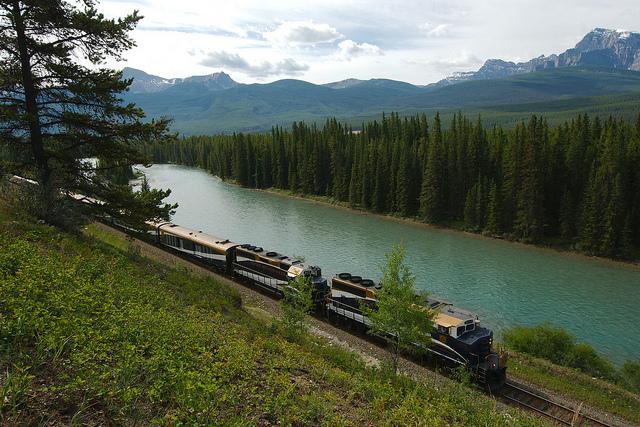What is the tree in the upper left corner?
Be succinct. Pine. Is this a freight train?
Concise answer only. No. Color is the first train?
Be succinct. Black and white. Is the train going straight or around a bend?
Write a very short answer. Straight. How many cars are on this train?
Short answer required. 6. 